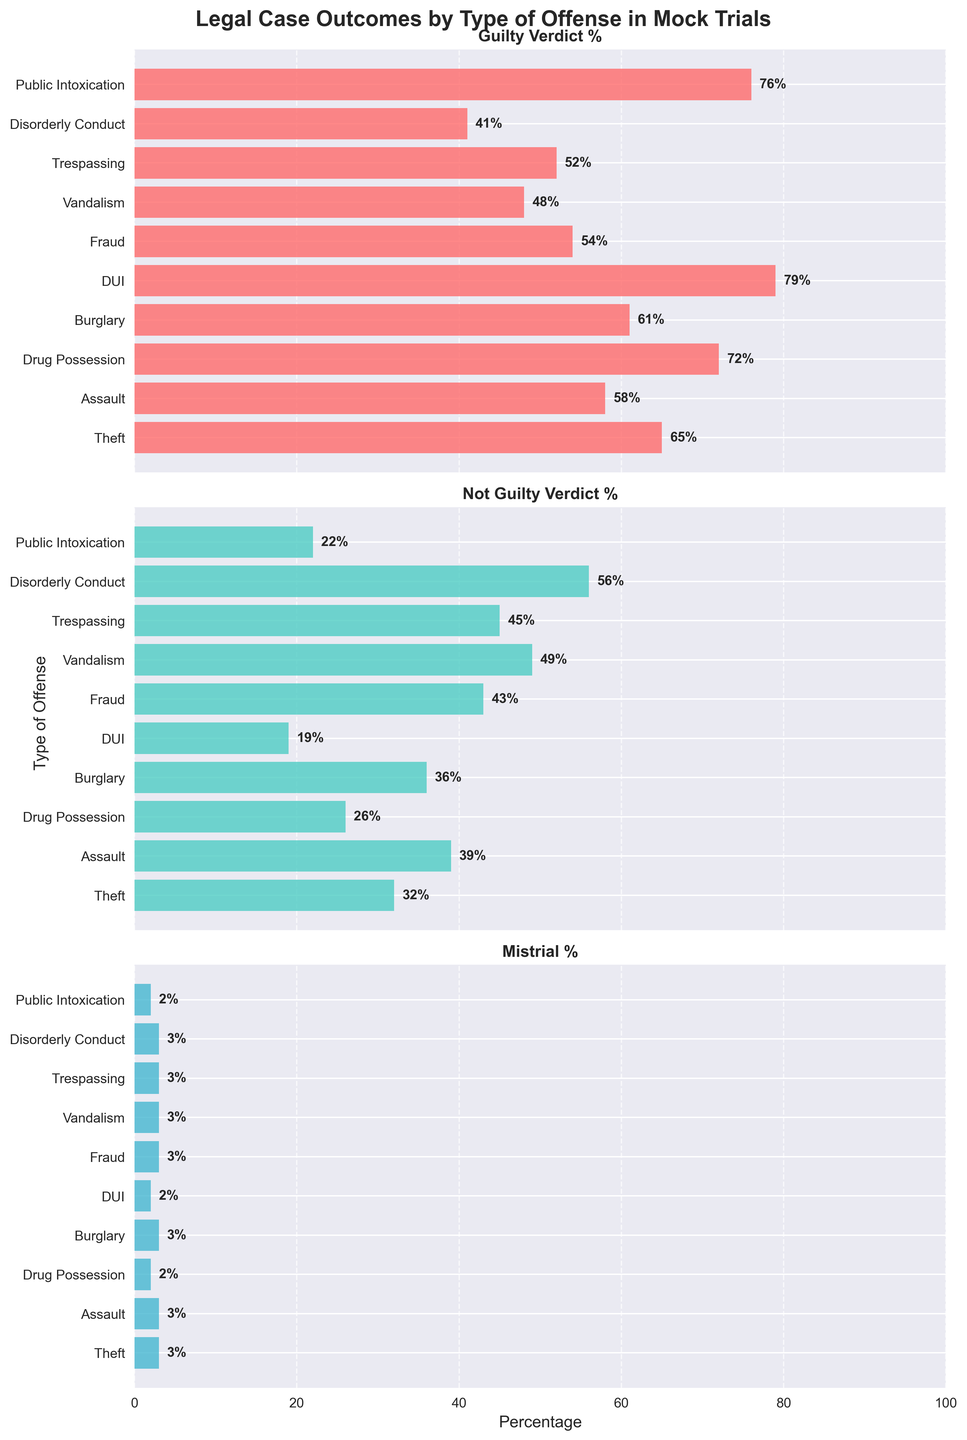Which type of offense has the highest guilty verdict percentage? The "Guilty Verdict %" subplot shows DUI with the tallest red bar reaching 79%.
Answer: DUI Which offense type has the smallest percentage of not guilty verdicts? In the "Not Guilty Verdict %" subplot, DUI again has the smallest green bar at 19%.
Answer: DUI What is the combined percentage of mistrials for all offense types? Summing the mistrial percentages from the "Mistrial %" subplot: 3 + 3 + 2 + 3 + 2 + 3 + 3 + 3 + 3 + 2 equals 27%.
Answer: 27% How do the guilty verdict percentages for drug possession and public intoxication compare? Checking the heights of the red bars in the "Guilty Verdict %" subplot, drug possession is at 72% and public intoxication is at 76%.
Answer: Public intoxication is higher What is the average not guilty verdict percentage across all types of offenses? Adding the not guilty verdict percentages: 32 + 39 + 26 + 36 + 19 + 43 + 49 + 45 + 56 + 22 = 367, then divide by 10 offenses equals 36.7%.
Answer: 36.7% Which offense type has the closest percentage between guilty and not guilty verdicts? In the "Guilty Verdict %" and "Not Guilty Verdict %" subplots, vandalism has 48% guilty and 49% not guilty, which are the closest.
Answer: Vandalism For the offense of assault, how much more likely is a guilty verdict compared to a not guilty verdict? In the case of assault, the red bar for guilty is 58% and the green bar for not guilty is 39%. The difference is 58% - 39% = 19%.
Answer: 19% more likely Which graph is representing the data such that all percentages are uniformly very close to each other? The mistrial percentages in the "Mistrial %" subplot are all around 2-3%, which are uniformly close.
Answer: Mistrial % How does the number of offenses with понад 50 % guilty verdict compare to those with less than 50 % not guilty verdict? In the "Guilty Verdict %" subplot, there are 7 offenses with понад 50%: Theft, Assault, Drug Possession, Burglary, DUI, Public Intoxication, and Fraud. In the "Not Guilty Verdict %" subplot, there are 4 offenses with less than 50%: Theft, Drug Possession, DUI, and Public Intoxication.
Answer: 7 for guilty, 4 for not guilty Based on the data, which offense appears to have the greatest likelihood of being concluded as not guilty? The "Not Guilty Verdict %" subplot shows Disorderly Conduct with the tallest green bar at 56%.
Answer: Disorderly Conduct 